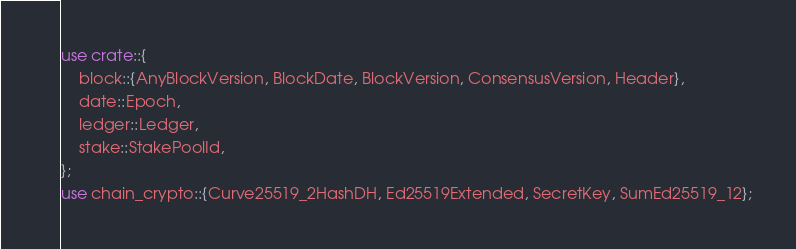Convert code to text. <code><loc_0><loc_0><loc_500><loc_500><_Rust_>use crate::{
    block::{AnyBlockVersion, BlockDate, BlockVersion, ConsensusVersion, Header},
    date::Epoch,
    ledger::Ledger,
    stake::StakePoolId,
};
use chain_crypto::{Curve25519_2HashDH, Ed25519Extended, SecretKey, SumEd25519_12};</code> 